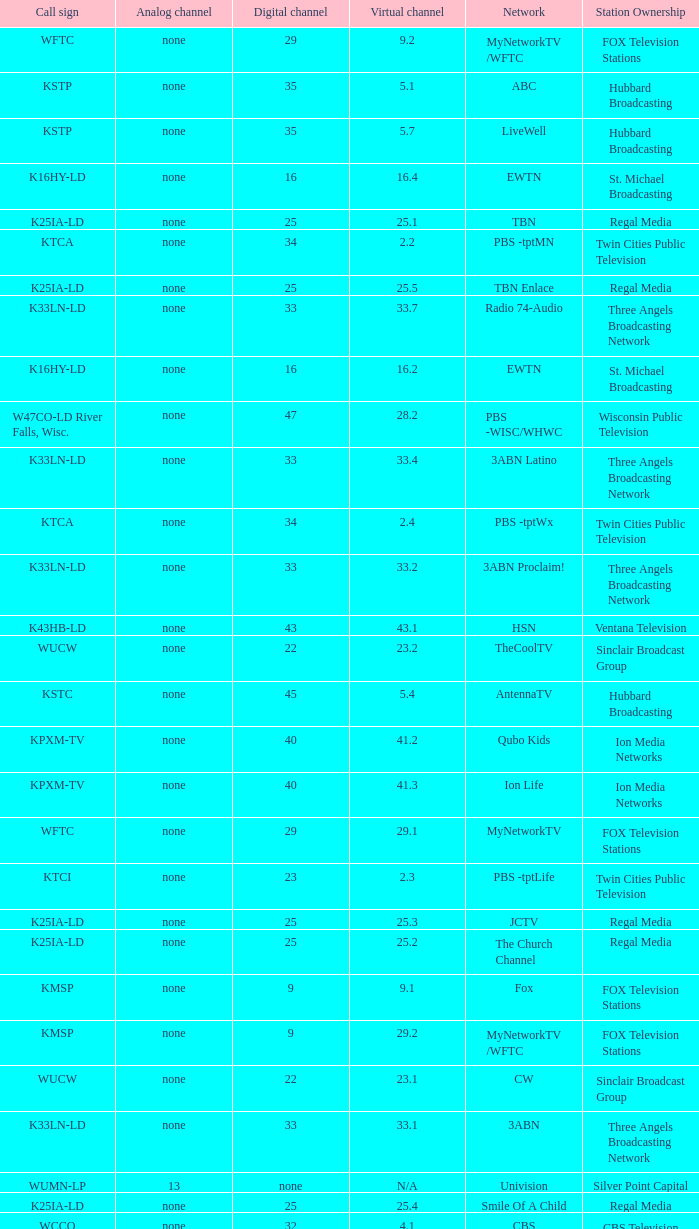Virtual channel of 16.5 has what call sign? K16HY-LD. 